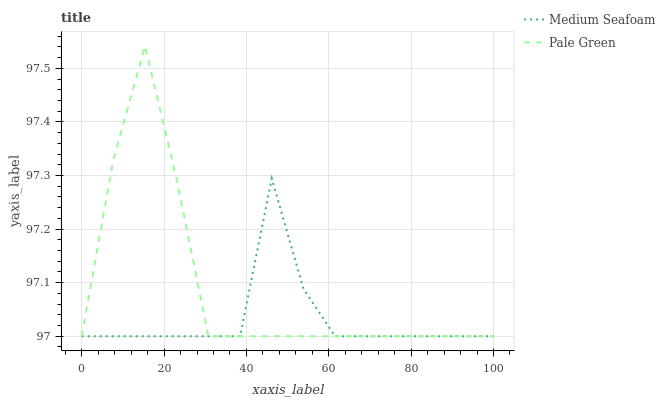Does Medium Seafoam have the minimum area under the curve?
Answer yes or no. Yes. Does Pale Green have the maximum area under the curve?
Answer yes or no. Yes. Does Medium Seafoam have the maximum area under the curve?
Answer yes or no. No. Is Pale Green the smoothest?
Answer yes or no. Yes. Is Medium Seafoam the roughest?
Answer yes or no. Yes. Is Medium Seafoam the smoothest?
Answer yes or no. No. Does Pale Green have the lowest value?
Answer yes or no. Yes. Does Pale Green have the highest value?
Answer yes or no. Yes. Does Medium Seafoam have the highest value?
Answer yes or no. No. Does Pale Green intersect Medium Seafoam?
Answer yes or no. Yes. Is Pale Green less than Medium Seafoam?
Answer yes or no. No. Is Pale Green greater than Medium Seafoam?
Answer yes or no. No. 